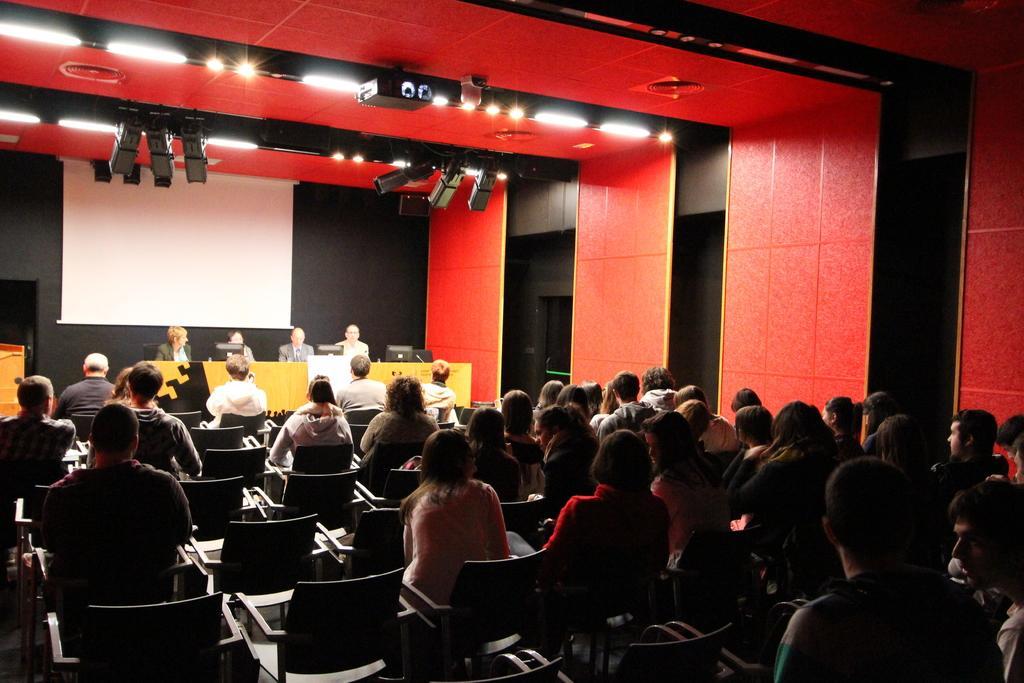Could you give a brief overview of what you see in this image? In this image i can see a group of people sitting ,at the back ground i can see few persons sitting on the stage, screen at the top i can see a light. 